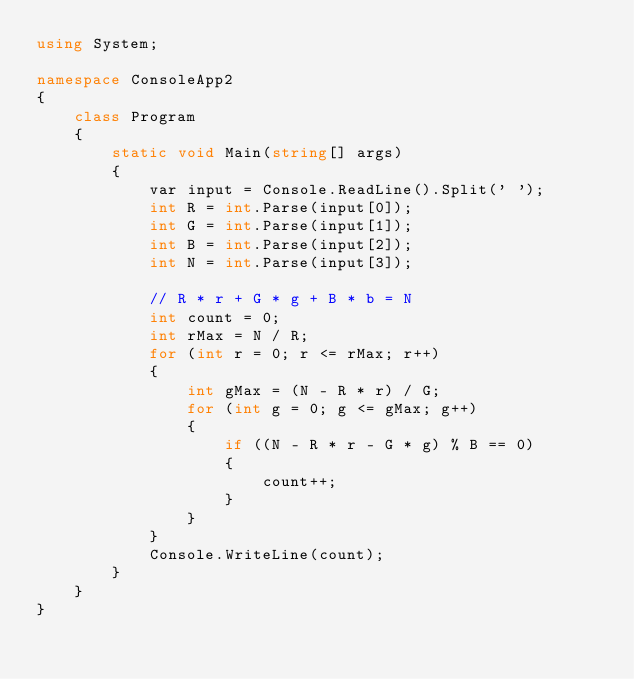<code> <loc_0><loc_0><loc_500><loc_500><_C#_>using System;

namespace ConsoleApp2
{
	class Program
	{
		static void Main(string[] args)
		{
			var input = Console.ReadLine().Split(' ');
			int R = int.Parse(input[0]);
			int G = int.Parse(input[1]);
			int B = int.Parse(input[2]);
			int N = int.Parse(input[3]);

			// R * r + G * g + B * b = N
			int count = 0;
			int rMax = N / R;
			for (int r = 0; r <= rMax; r++)
			{
				int gMax = (N - R * r) / G;
				for (int g = 0; g <= gMax; g++)
				{
					if ((N - R * r - G * g) % B == 0)
					{
						count++;
					}
				}
			}
			Console.WriteLine(count);
		}
	}
}
</code> 